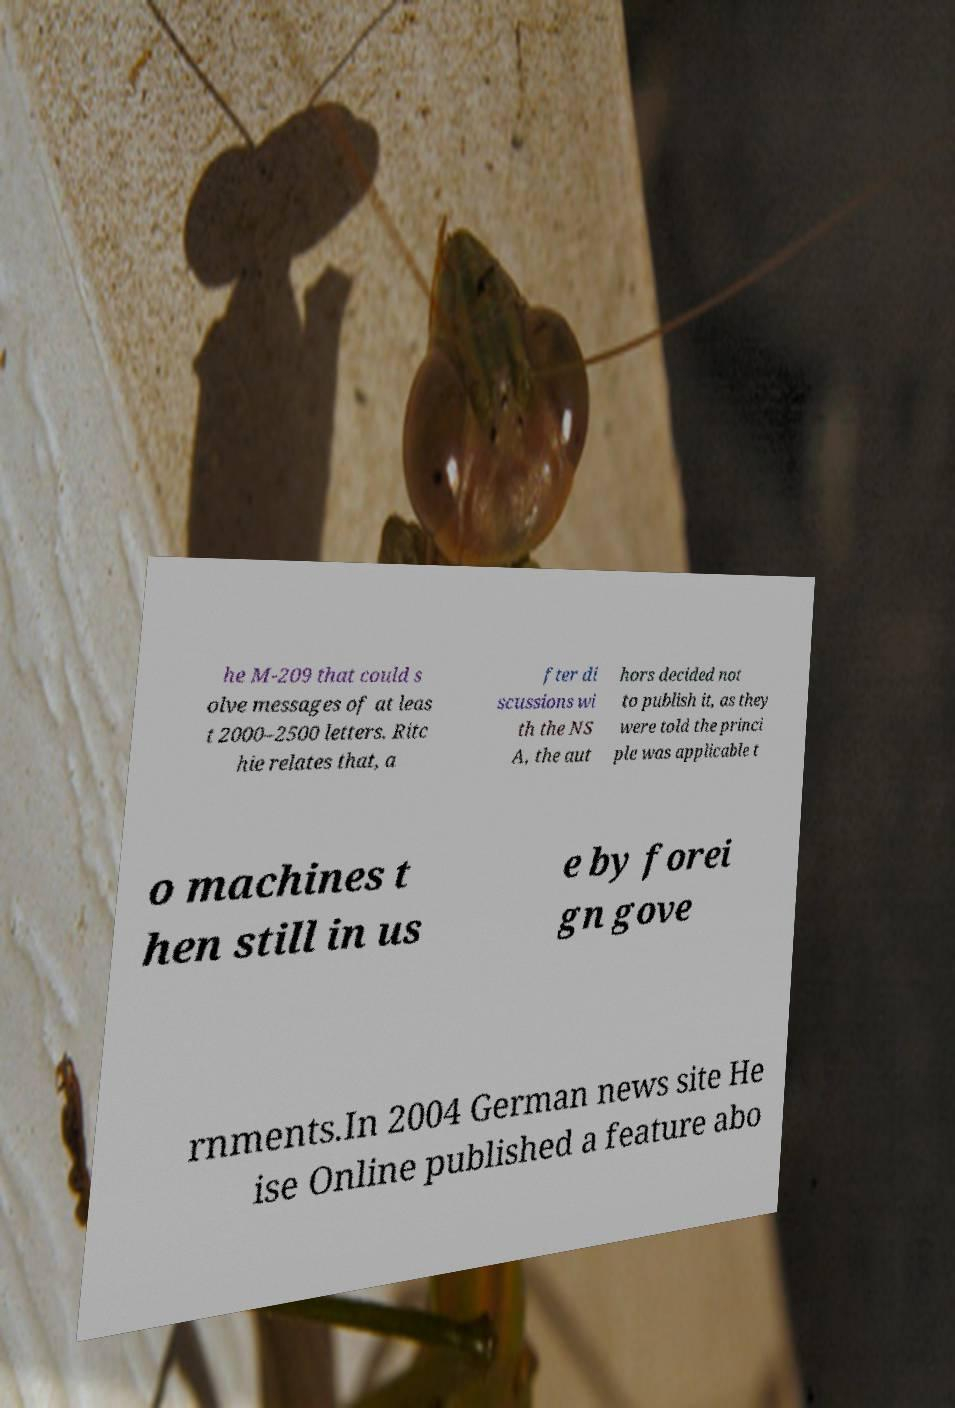Please identify and transcribe the text found in this image. he M-209 that could s olve messages of at leas t 2000–2500 letters. Ritc hie relates that, a fter di scussions wi th the NS A, the aut hors decided not to publish it, as they were told the princi ple was applicable t o machines t hen still in us e by forei gn gove rnments.In 2004 German news site He ise Online published a feature abo 